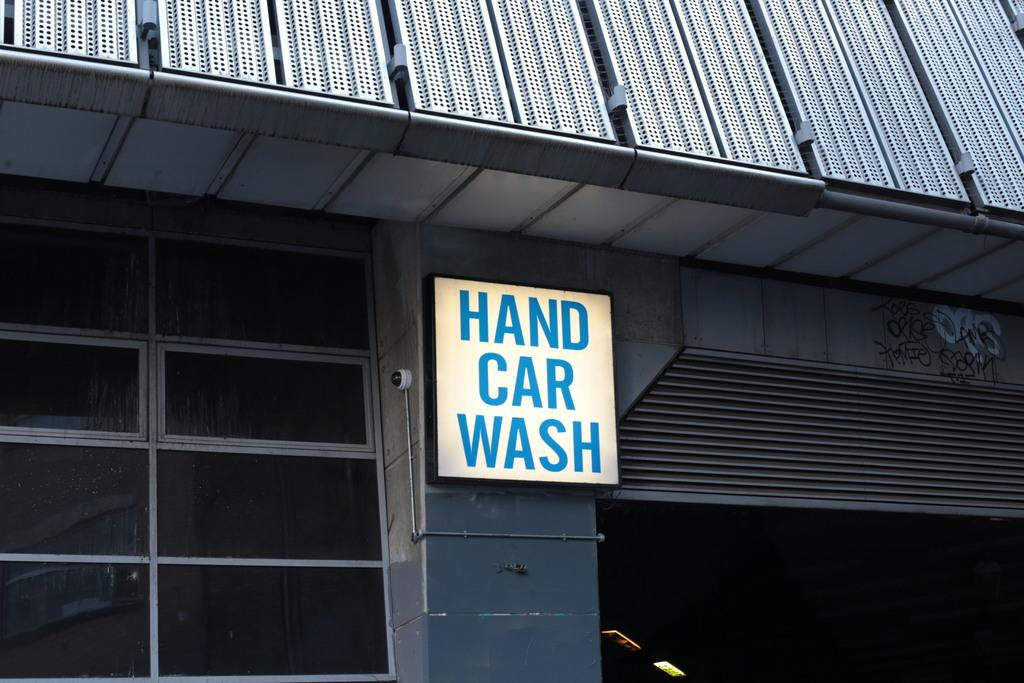What type of structure is present in the image? There is a building in the image. What can be seen in the center of the building? There is a board in the center of the building. What is located beside the board? There is a camera beside the board. What is on the right side of the building? There is a shelter on the right side of the building. What feature can be observed on the left side of the building? There are windows visible on the left side of the building. What type of locket is hanging from the camera in the image? There is no locket hanging from the camera in the image. What invention is being demonstrated in the image? There is no invention being demonstrated in the image; it simply shows a building with a board, camera, shelter, and windows. 